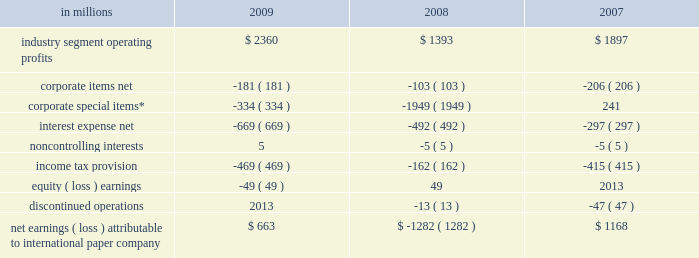Item 7 .
Management 2019s discussion and analysis of financial condition and results of operations executive summary international paper company reported net sales of $ 23.4 billion in 2009 , compared with $ 24.8 billion in 2008 and $ 21.9 billion in 2007 .
Net earnings totaled $ 663 million in 2009 , including $ 1.4 billion of alter- native fuel mixture credits and $ 853 million of charges to restructure ongoing businesses , com- pared with a loss of $ 1.3 billion in 2008 , which included a $ 1.8 billion goodwill impairment charge .
Net earnings in 2007 totaled $ 1.2 billion .
The company performed well in 2009 considering the magnitude of the challenges it faced , both domestically and around the world .
Despite weak global economic conditions , the company generated record cash flow from operations , enabling us to reduce long-term debt by $ 3.1 billion while increas- ing cash balances by approximately $ 800 million .
Also during 2009 , the company incurred 3.6 million tons of downtime , including 1.1 million tons asso- ciated with the shutdown of production capacity in our north american mill system to continue to match our production to our customers 2019 needs .
These actions should result in higher operating rates , lower fixed costs and lower payroll costs in 2010 and beyond .
Furthermore , the realization of integration synergies in our u.s .
Industrial packaging business and overhead reduction initiatives across the com- pany position international paper to benefit from a lower cost profile in future years .
As 2010 begins , we expect that first-quarter oper- ations will continue to be challenging .
In addition to being a seasonally slow quarter for many of our businesses , poor harvesting weather conditions in the u.s .
South and increasing competition for lim- ited supplies of recycled fiber are expected to lead to further increases in fiber costs for our u.s .
Mills .
Planned maintenance outage expenses will also be higher than in the 2009 fourth quarter .
However , we have announced product price increases for our major global manufacturing businesses , and while these actions may not have a significant effect on first-quarter results , we believe that the benefits beginning in the second quarter will be significant .
Additionally , we expect to benefit from the capacity management , cost reduction and integration synergy actions taken during 2009 .
As a result , the company remains positive about projected operating results in 2010 , with improved earnings versus 2009 expected in all major businesses .
We will continue to focus on aggressive cost management and strong cash flow generation as 2010 progresses .
Results of operations industry segment operating profits are used by inter- national paper 2019s management to measure the earn- ings performance of its businesses .
Management believes that this measure allows a better under- standing of trends in costs , operating efficiencies , prices and volumes .
Industry segment operating profits are defined as earnings before taxes , equity earnings , noncontrolling interests , interest expense , corporate items and corporate special items .
Industry segment operating profits are defined by the securities and exchange commission as a non-gaap financial measure , and are not gaap alternatives to net income or any other operating measure prescribed by accounting principles gen- erally accepted in the united states .
International paper operates in six segments : industrial packaging , printing papers , consumer packaging , distribution , forest products , and spe- cialty businesses and other .
The table shows the components of net earnings ( loss ) attributable to international paper company for each of the last three years : in millions 2009 2008 2007 .
Net earnings ( loss ) attributable to international paper company $ 663 $ ( 1282 ) $ 1168 * corporate special items include restructuring and other charg- es , goodwill impairment charges , gains on transformation plan forestland sales and net losses ( gains ) on sales and impairments of businesses .
Industry segment operating profits of $ 2.4 billion were $ 967 million higher in 2009 than in 2008 .
Oper- ating profits benefited from lower energy and raw material costs ( $ 447 million ) , lower distribution costs ( $ 142 million ) , favorable manufacturing operating costs ( $ 481 million ) , incremental earnings from the cbpr business acquired in the third quarter of 2008 ( $ 202 million ) , and other items ( $ 35 million ) , offset by lower average sales price realizations ( $ 444 million ) , lower sales volumes and increased lack-of-order downtime ( $ 684 million ) , unfavorable .
What is the average value of interest expense net , in millions? 
Rationale: it is the sum of all values divided by three .
Computations: table_average(interest expense net, none)
Answer: -486.0. 